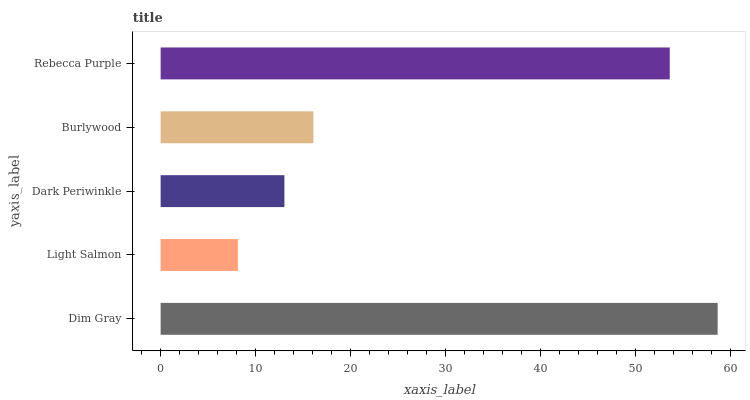Is Light Salmon the minimum?
Answer yes or no. Yes. Is Dim Gray the maximum?
Answer yes or no. Yes. Is Dark Periwinkle the minimum?
Answer yes or no. No. Is Dark Periwinkle the maximum?
Answer yes or no. No. Is Dark Periwinkle greater than Light Salmon?
Answer yes or no. Yes. Is Light Salmon less than Dark Periwinkle?
Answer yes or no. Yes. Is Light Salmon greater than Dark Periwinkle?
Answer yes or no. No. Is Dark Periwinkle less than Light Salmon?
Answer yes or no. No. Is Burlywood the high median?
Answer yes or no. Yes. Is Burlywood the low median?
Answer yes or no. Yes. Is Light Salmon the high median?
Answer yes or no. No. Is Light Salmon the low median?
Answer yes or no. No. 